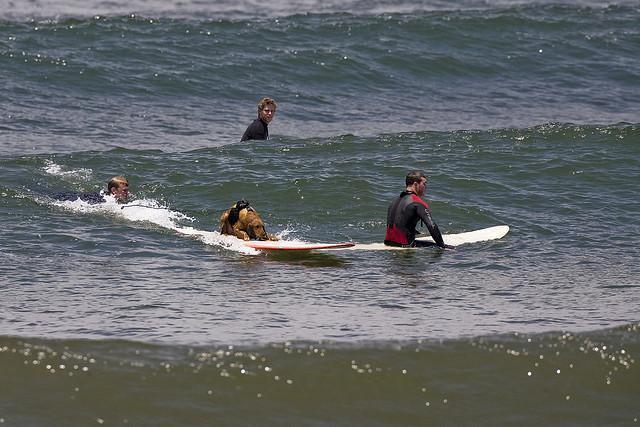What is the dog doing?
Choose the correct response and explain in the format: 'Answer: answer
Rationale: rationale.'
Options: Biting, swimming, surfing, dog paddling. Answer: surfing.
Rationale: A dog is on surfboard in the water. 